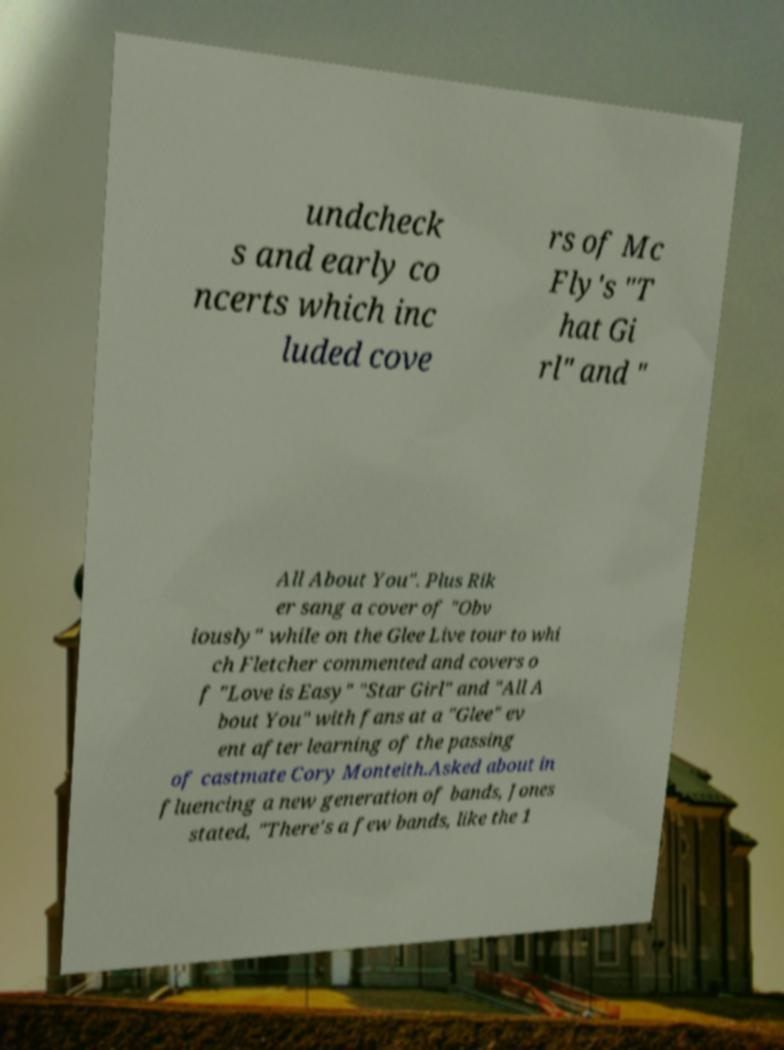What messages or text are displayed in this image? I need them in a readable, typed format. undcheck s and early co ncerts which inc luded cove rs of Mc Fly's "T hat Gi rl" and " All About You". Plus Rik er sang a cover of "Obv iously" while on the Glee Live tour to whi ch Fletcher commented and covers o f "Love is Easy" "Star Girl" and "All A bout You" with fans at a "Glee" ev ent after learning of the passing of castmate Cory Monteith.Asked about in fluencing a new generation of bands, Jones stated, "There's a few bands, like the 1 